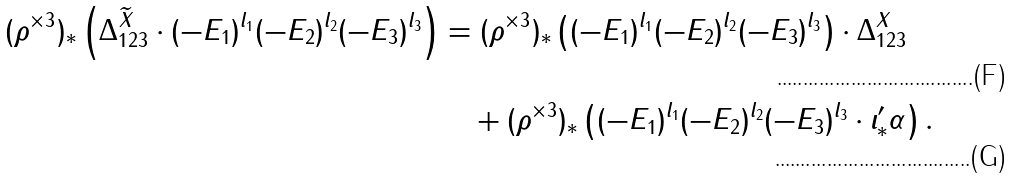Convert formula to latex. <formula><loc_0><loc_0><loc_500><loc_500>( \rho ^ { \times 3 } ) _ { * } \left ( \Delta _ { 1 2 3 } ^ { \widetilde { X } } \cdot ( - E _ { 1 } ) ^ { l _ { 1 } } ( - E _ { 2 } ) ^ { l _ { 2 } } ( - E _ { 3 } ) ^ { l _ { 3 } } \right ) & = ( \rho ^ { \times 3 } ) _ { * } \left ( ( - E _ { 1 } ) ^ { l _ { 1 } } ( - E _ { 2 } ) ^ { l _ { 2 } } ( - E _ { 3 } ) ^ { l _ { 3 } } \right ) \cdot \Delta _ { 1 2 3 } ^ { X } \\ & \quad + ( \rho ^ { \times 3 } ) _ { * } \left ( ( - E _ { 1 } ) ^ { l _ { 1 } } ( - E _ { 2 } ) ^ { l _ { 2 } } ( - E _ { 3 } ) ^ { l _ { 3 } } \cdot \iota ^ { \prime } _ { * } \alpha \right ) .</formula> 